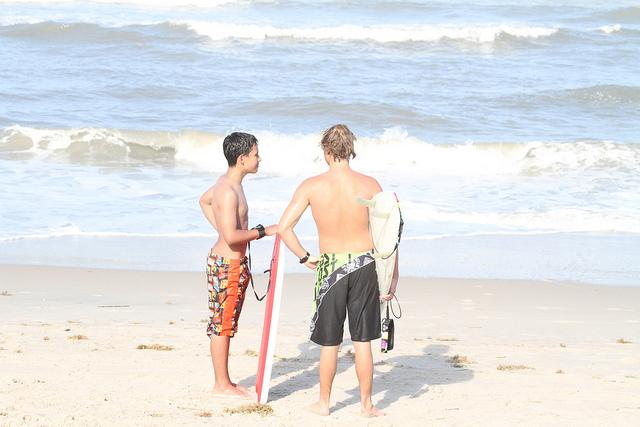What is this place?
Short answer required. Beach. Are these people in the water?
Short answer required. No. How close are the surfers the wet sand portion of this photo?
Concise answer only. 5 ft. 